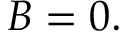Convert formula to latex. <formula><loc_0><loc_0><loc_500><loc_500>B = 0 .</formula> 